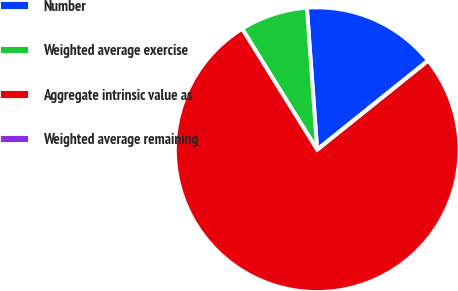<chart> <loc_0><loc_0><loc_500><loc_500><pie_chart><fcel>Number<fcel>Weighted average exercise<fcel>Aggregate intrinsic value as<fcel>Weighted average remaining<nl><fcel>15.38%<fcel>7.69%<fcel>76.92%<fcel>0.0%<nl></chart> 